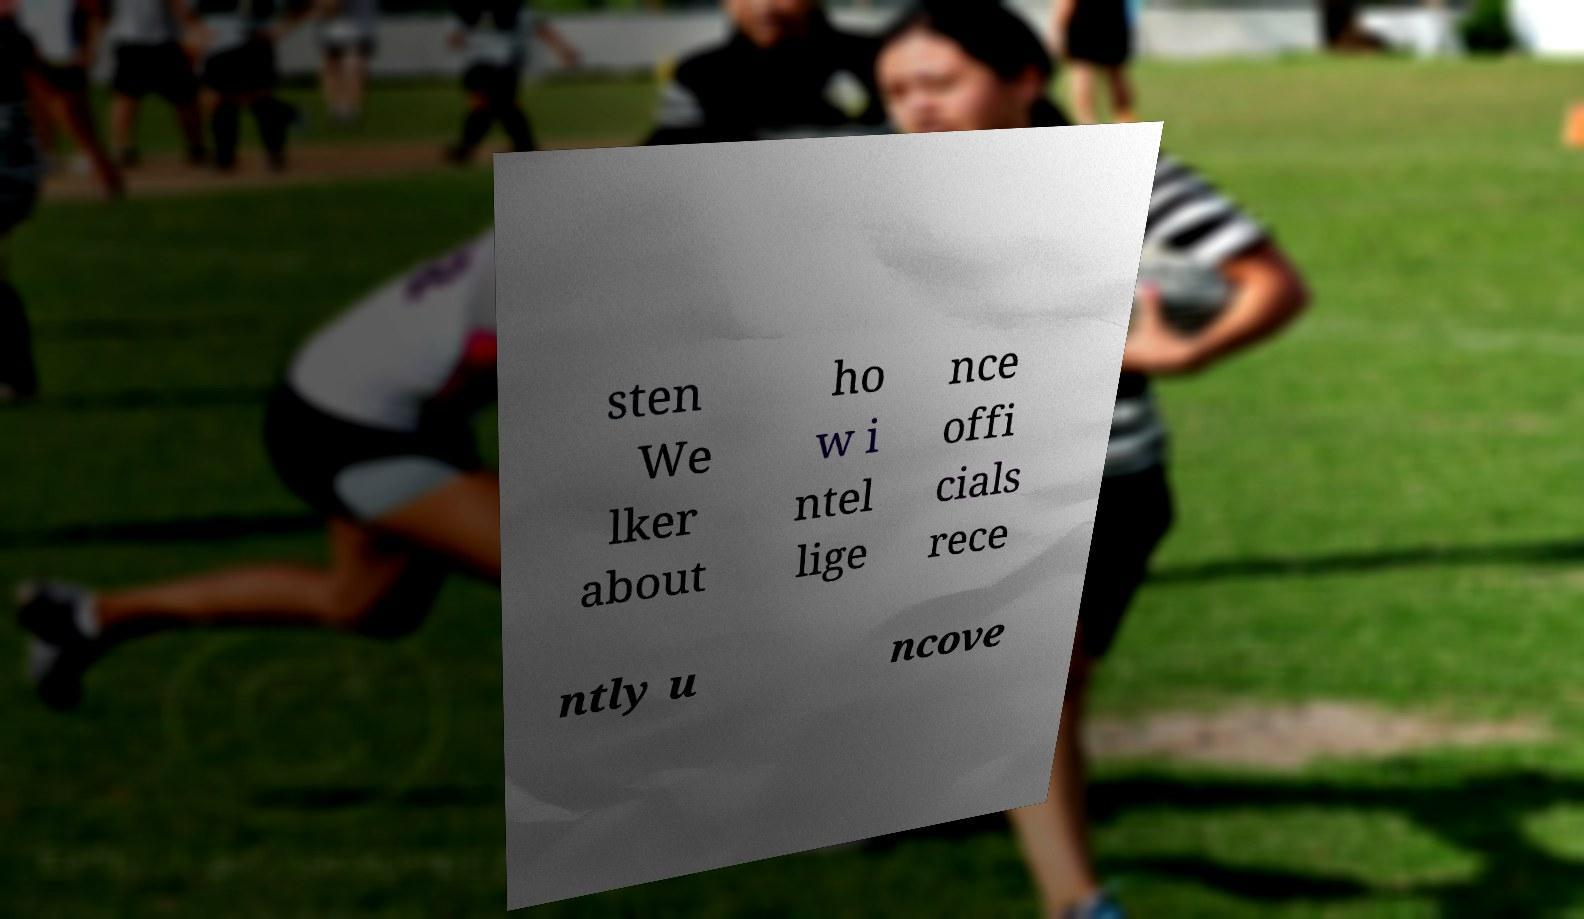Can you accurately transcribe the text from the provided image for me? sten We lker about ho w i ntel lige nce offi cials rece ntly u ncove 